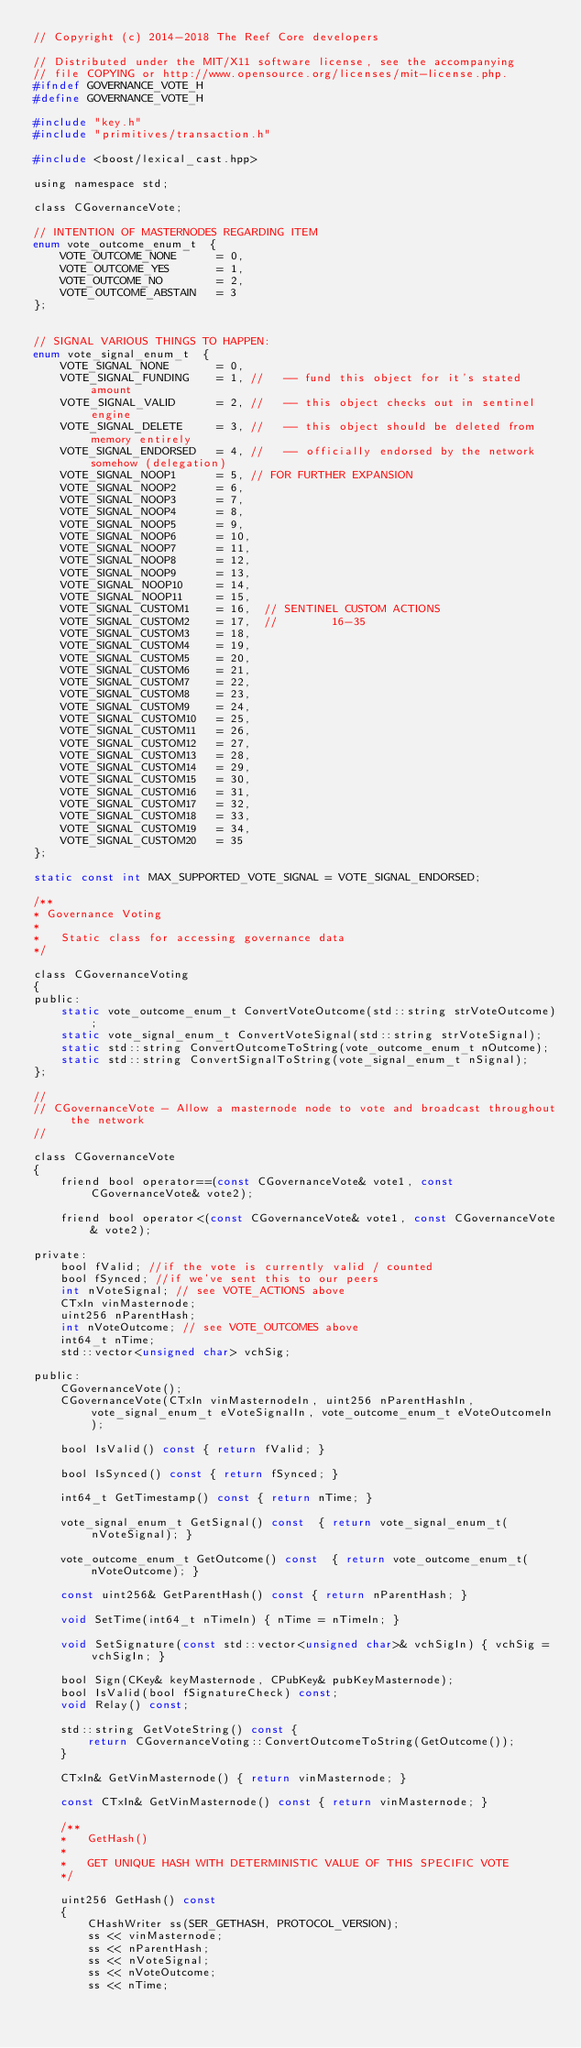Convert code to text. <code><loc_0><loc_0><loc_500><loc_500><_C_>// Copyright (c) 2014-2018 The Reef Core developers

// Distributed under the MIT/X11 software license, see the accompanying
// file COPYING or http://www.opensource.org/licenses/mit-license.php.
#ifndef GOVERNANCE_VOTE_H
#define GOVERNANCE_VOTE_H

#include "key.h"
#include "primitives/transaction.h"

#include <boost/lexical_cast.hpp>

using namespace std;

class CGovernanceVote;

// INTENTION OF MASTERNODES REGARDING ITEM
enum vote_outcome_enum_t  {
    VOTE_OUTCOME_NONE      = 0,
    VOTE_OUTCOME_YES       = 1,
    VOTE_OUTCOME_NO        = 2,
    VOTE_OUTCOME_ABSTAIN   = 3
};


// SIGNAL VARIOUS THINGS TO HAPPEN:
enum vote_signal_enum_t  {
    VOTE_SIGNAL_NONE       = 0,
    VOTE_SIGNAL_FUNDING    = 1, //   -- fund this object for it's stated amount
    VOTE_SIGNAL_VALID      = 2, //   -- this object checks out in sentinel engine
    VOTE_SIGNAL_DELETE     = 3, //   -- this object should be deleted from memory entirely
    VOTE_SIGNAL_ENDORSED   = 4, //   -- officially endorsed by the network somehow (delegation)
    VOTE_SIGNAL_NOOP1      = 5, // FOR FURTHER EXPANSION
    VOTE_SIGNAL_NOOP2      = 6,
    VOTE_SIGNAL_NOOP3      = 7,
    VOTE_SIGNAL_NOOP4      = 8,
    VOTE_SIGNAL_NOOP5      = 9,
    VOTE_SIGNAL_NOOP6      = 10,
    VOTE_SIGNAL_NOOP7      = 11,
    VOTE_SIGNAL_NOOP8      = 12,
    VOTE_SIGNAL_NOOP9      = 13,
    VOTE_SIGNAL_NOOP10     = 14,
    VOTE_SIGNAL_NOOP11     = 15,
    VOTE_SIGNAL_CUSTOM1    = 16,  // SENTINEL CUSTOM ACTIONS
    VOTE_SIGNAL_CUSTOM2    = 17,  //        16-35
    VOTE_SIGNAL_CUSTOM3    = 18,
    VOTE_SIGNAL_CUSTOM4    = 19,
    VOTE_SIGNAL_CUSTOM5    = 20,
    VOTE_SIGNAL_CUSTOM6    = 21,
    VOTE_SIGNAL_CUSTOM7    = 22,
    VOTE_SIGNAL_CUSTOM8    = 23,
    VOTE_SIGNAL_CUSTOM9    = 24,
    VOTE_SIGNAL_CUSTOM10   = 25,
    VOTE_SIGNAL_CUSTOM11   = 26,
    VOTE_SIGNAL_CUSTOM12   = 27,
    VOTE_SIGNAL_CUSTOM13   = 28,
    VOTE_SIGNAL_CUSTOM14   = 29,
    VOTE_SIGNAL_CUSTOM15   = 30,
    VOTE_SIGNAL_CUSTOM16   = 31,
    VOTE_SIGNAL_CUSTOM17   = 32,
    VOTE_SIGNAL_CUSTOM18   = 33,
    VOTE_SIGNAL_CUSTOM19   = 34,
    VOTE_SIGNAL_CUSTOM20   = 35
};

static const int MAX_SUPPORTED_VOTE_SIGNAL = VOTE_SIGNAL_ENDORSED;

/**
* Governance Voting
*
*   Static class for accessing governance data
*/

class CGovernanceVoting
{
public:
    static vote_outcome_enum_t ConvertVoteOutcome(std::string strVoteOutcome);
    static vote_signal_enum_t ConvertVoteSignal(std::string strVoteSignal);
    static std::string ConvertOutcomeToString(vote_outcome_enum_t nOutcome);
    static std::string ConvertSignalToString(vote_signal_enum_t nSignal);
};

//
// CGovernanceVote - Allow a masternode node to vote and broadcast throughout the network
//

class CGovernanceVote
{
    friend bool operator==(const CGovernanceVote& vote1, const CGovernanceVote& vote2);

    friend bool operator<(const CGovernanceVote& vote1, const CGovernanceVote& vote2);

private:
    bool fValid; //if the vote is currently valid / counted
    bool fSynced; //if we've sent this to our peers
    int nVoteSignal; // see VOTE_ACTIONS above
    CTxIn vinMasternode;
    uint256 nParentHash;
    int nVoteOutcome; // see VOTE_OUTCOMES above
    int64_t nTime;
    std::vector<unsigned char> vchSig;

public:
    CGovernanceVote();
    CGovernanceVote(CTxIn vinMasternodeIn, uint256 nParentHashIn, vote_signal_enum_t eVoteSignalIn, vote_outcome_enum_t eVoteOutcomeIn);

    bool IsValid() const { return fValid; }

    bool IsSynced() const { return fSynced; }

    int64_t GetTimestamp() const { return nTime; }

    vote_signal_enum_t GetSignal() const  { return vote_signal_enum_t(nVoteSignal); }

    vote_outcome_enum_t GetOutcome() const  { return vote_outcome_enum_t(nVoteOutcome); }

    const uint256& GetParentHash() const { return nParentHash; }

    void SetTime(int64_t nTimeIn) { nTime = nTimeIn; }

    void SetSignature(const std::vector<unsigned char>& vchSigIn) { vchSig = vchSigIn; }

    bool Sign(CKey& keyMasternode, CPubKey& pubKeyMasternode);
    bool IsValid(bool fSignatureCheck) const;
    void Relay() const;

    std::string GetVoteString() const {
        return CGovernanceVoting::ConvertOutcomeToString(GetOutcome());
    }

    CTxIn& GetVinMasternode() { return vinMasternode; }

    const CTxIn& GetVinMasternode() const { return vinMasternode; }

    /**
    *   GetHash()
    *
    *   GET UNIQUE HASH WITH DETERMINISTIC VALUE OF THIS SPECIFIC VOTE
    */

    uint256 GetHash() const
    {
        CHashWriter ss(SER_GETHASH, PROTOCOL_VERSION);
        ss << vinMasternode;
        ss << nParentHash;
        ss << nVoteSignal;
        ss << nVoteOutcome;
        ss << nTime;</code> 